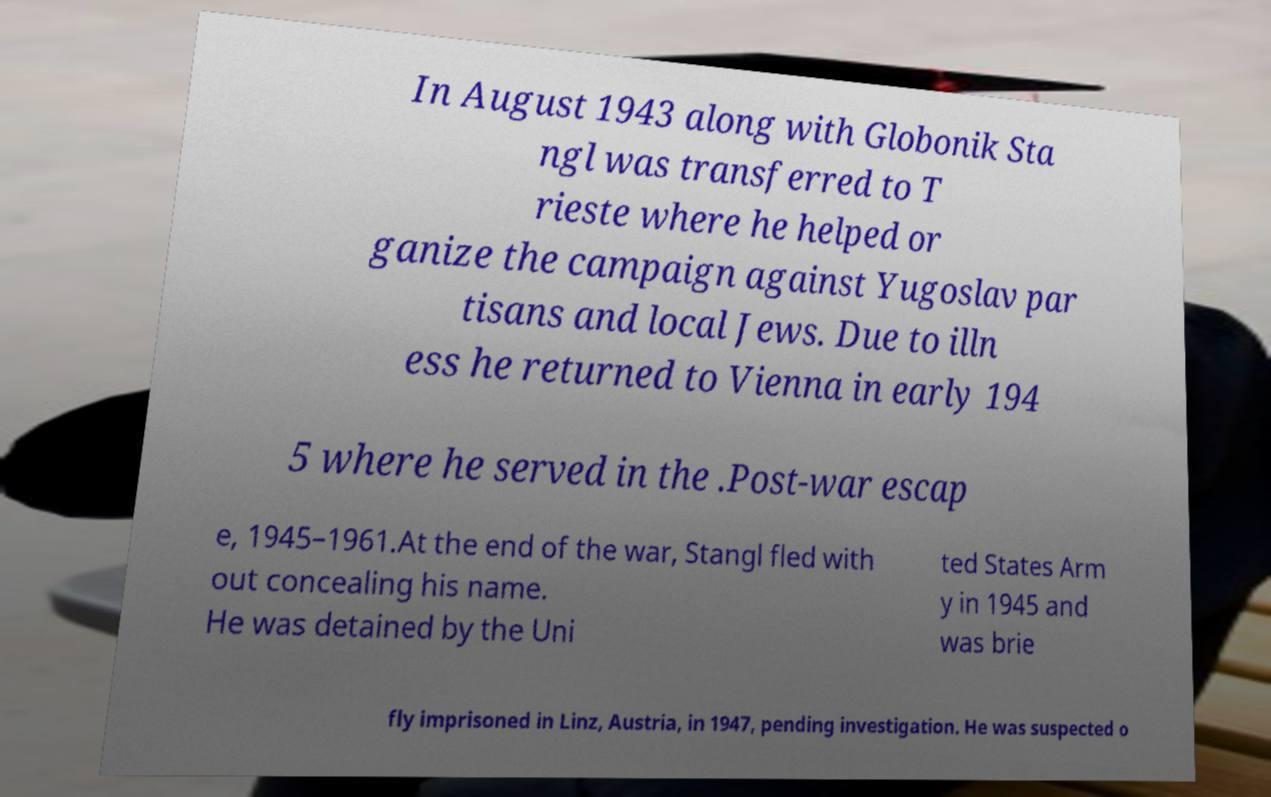Could you extract and type out the text from this image? In August 1943 along with Globonik Sta ngl was transferred to T rieste where he helped or ganize the campaign against Yugoslav par tisans and local Jews. Due to illn ess he returned to Vienna in early 194 5 where he served in the .Post-war escap e, 1945–1961.At the end of the war, Stangl fled with out concealing his name. He was detained by the Uni ted States Arm y in 1945 and was brie fly imprisoned in Linz, Austria, in 1947, pending investigation. He was suspected o 